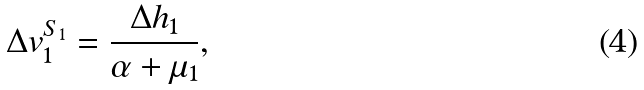Convert formula to latex. <formula><loc_0><loc_0><loc_500><loc_500>\Delta v ^ { S _ { 1 } } _ { 1 } = \frac { \Delta h _ { 1 } } { \alpha + \mu _ { 1 } } ,</formula> 